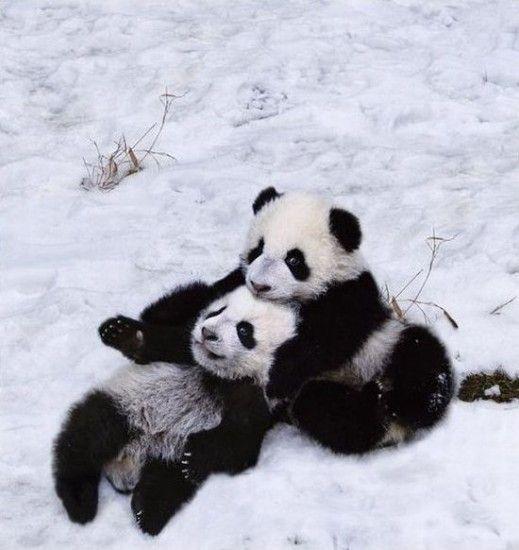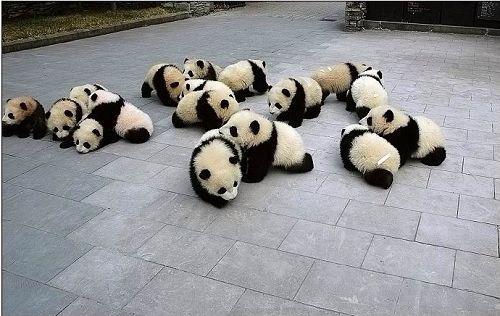The first image is the image on the left, the second image is the image on the right. Given the left and right images, does the statement "Exactly two pandas are playing in the snow in one of the images." hold true? Answer yes or no. Yes. The first image is the image on the left, the second image is the image on the right. Considering the images on both sides, is "At least one image shows many pandas on a white blanket surrounded by wooden rails, like a crib." valid? Answer yes or no. No. 